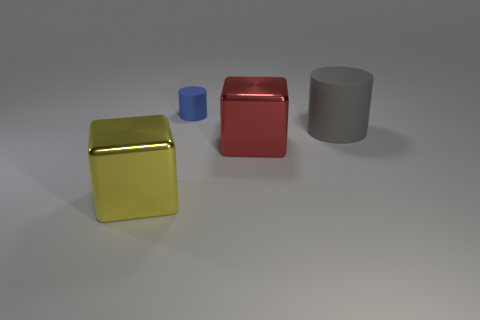Add 1 brown balls. How many objects exist? 5 Subtract all small green shiny cylinders. Subtract all small matte things. How many objects are left? 3 Add 1 blue cylinders. How many blue cylinders are left? 2 Add 3 red rubber objects. How many red rubber objects exist? 3 Subtract 0 green cylinders. How many objects are left? 4 